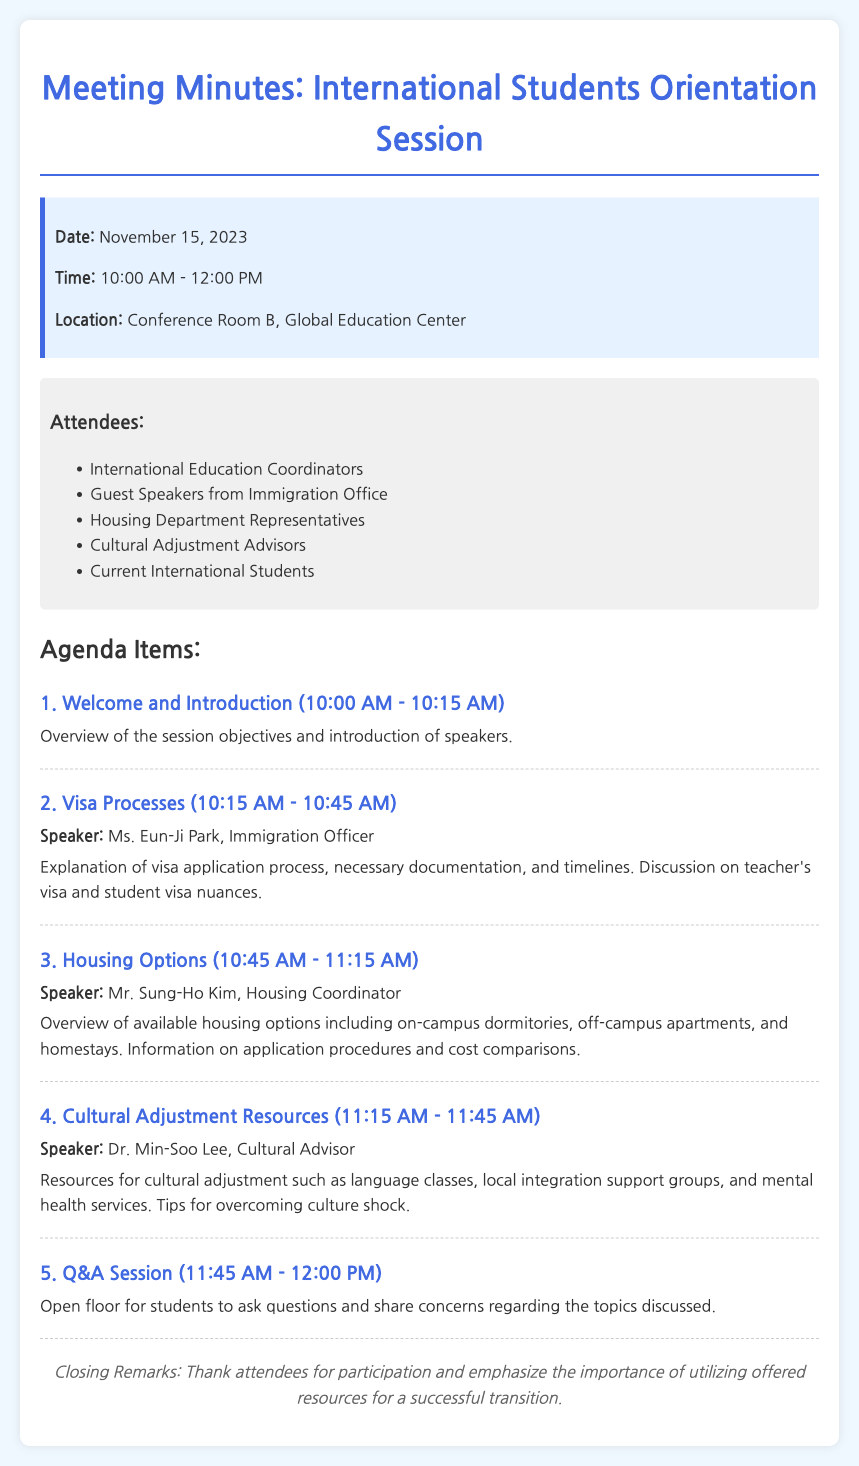What is the date of the meeting? The date of the meeting is specified in the document as November 15, 2023.
Answer: November 15, 2023 Who is the speaker for the visa processes? The document lists the speaker for the visa processes as Ms. Eun-Ji Park, Immigration Officer.
Answer: Ms. Eun-Ji Park What time does the cultural adjustment resources session start? The starting time of the cultural adjustment resources session can be found in the agenda section, which states it begins at 11:15 AM.
Answer: 11:15 AM How long is the Q&A session scheduled for? The document details that the Q&A session is scheduled for 15 minutes, from 11:45 AM to 12:00 PM.
Answer: 15 minutes What is one of the housing options mentioned? The document mentions several options, including on-campus dormitories as one of the housing options available.
Answer: on-campus dormitories What is the name of the location for the meeting? The location of the meeting is listed in the session info as Conference Room B, Global Education Center.
Answer: Conference Room B, Global Education Center What is emphasized in the closing remarks? The document states that the closing remarks emphasize the importance of utilizing offered resources for a successful transition.
Answer: utilizing offered resources for a successful transition Who are the attendees of the meeting? The list of attendees is provided in the document, including International Education Coordinators and Guest Speakers from Immigration Office.
Answer: International Education Coordinators, Guest Speakers from Immigration Office, Housing Department Representatives, Cultural Adjustment Advisors, Current International Students What type of resources are discussed for cultural adjustment? The document highlights that resources such as language classes and local integration support groups are discussed for cultural adjustment.
Answer: language classes, local integration support groups 